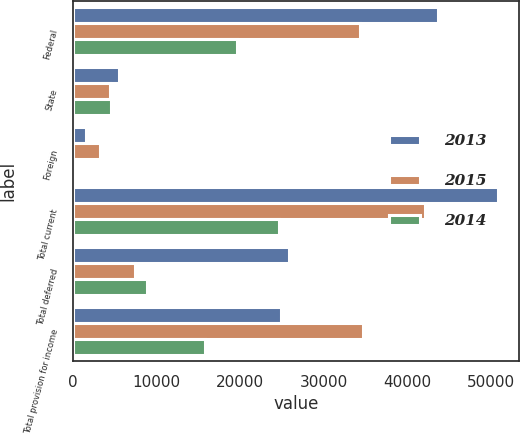Convert chart. <chart><loc_0><loc_0><loc_500><loc_500><stacked_bar_chart><ecel><fcel>Federal<fcel>State<fcel>Foreign<fcel>Total current<fcel>Total deferred<fcel>Total provision for income<nl><fcel>2013<fcel>43706<fcel>5500<fcel>1588<fcel>50794<fcel>25887<fcel>24907<nl><fcel>2015<fcel>34314<fcel>4493<fcel>3306<fcel>42113<fcel>7455<fcel>34658<nl><fcel>2014<fcel>19631<fcel>4602<fcel>413<fcel>24646<fcel>8831<fcel>15815<nl></chart> 